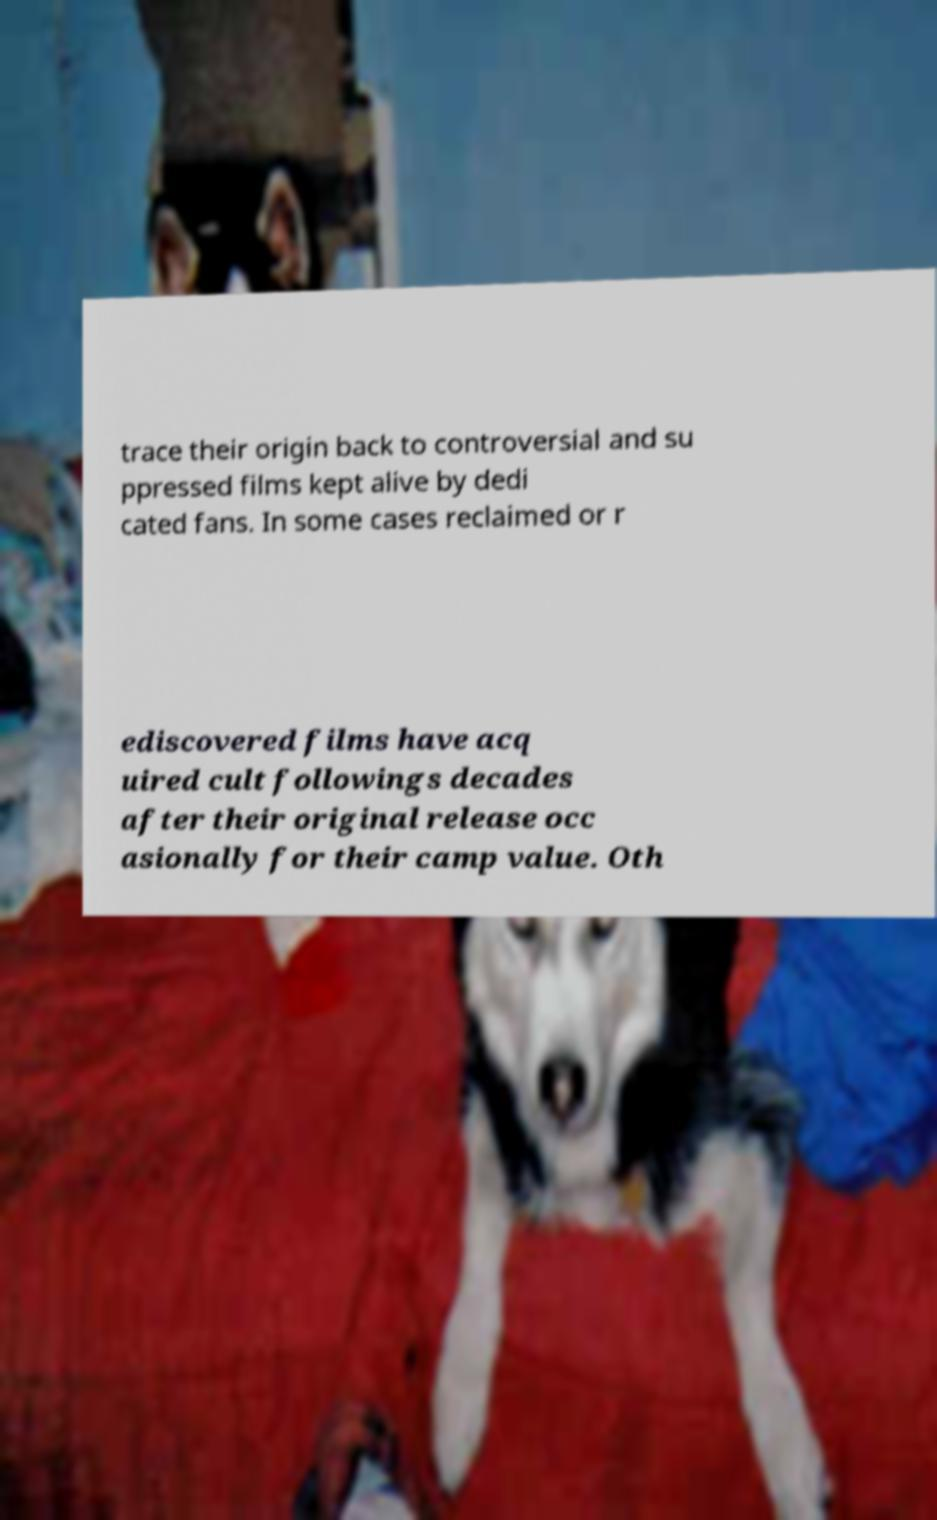Could you extract and type out the text from this image? trace their origin back to controversial and su ppressed films kept alive by dedi cated fans. In some cases reclaimed or r ediscovered films have acq uired cult followings decades after their original release occ asionally for their camp value. Oth 